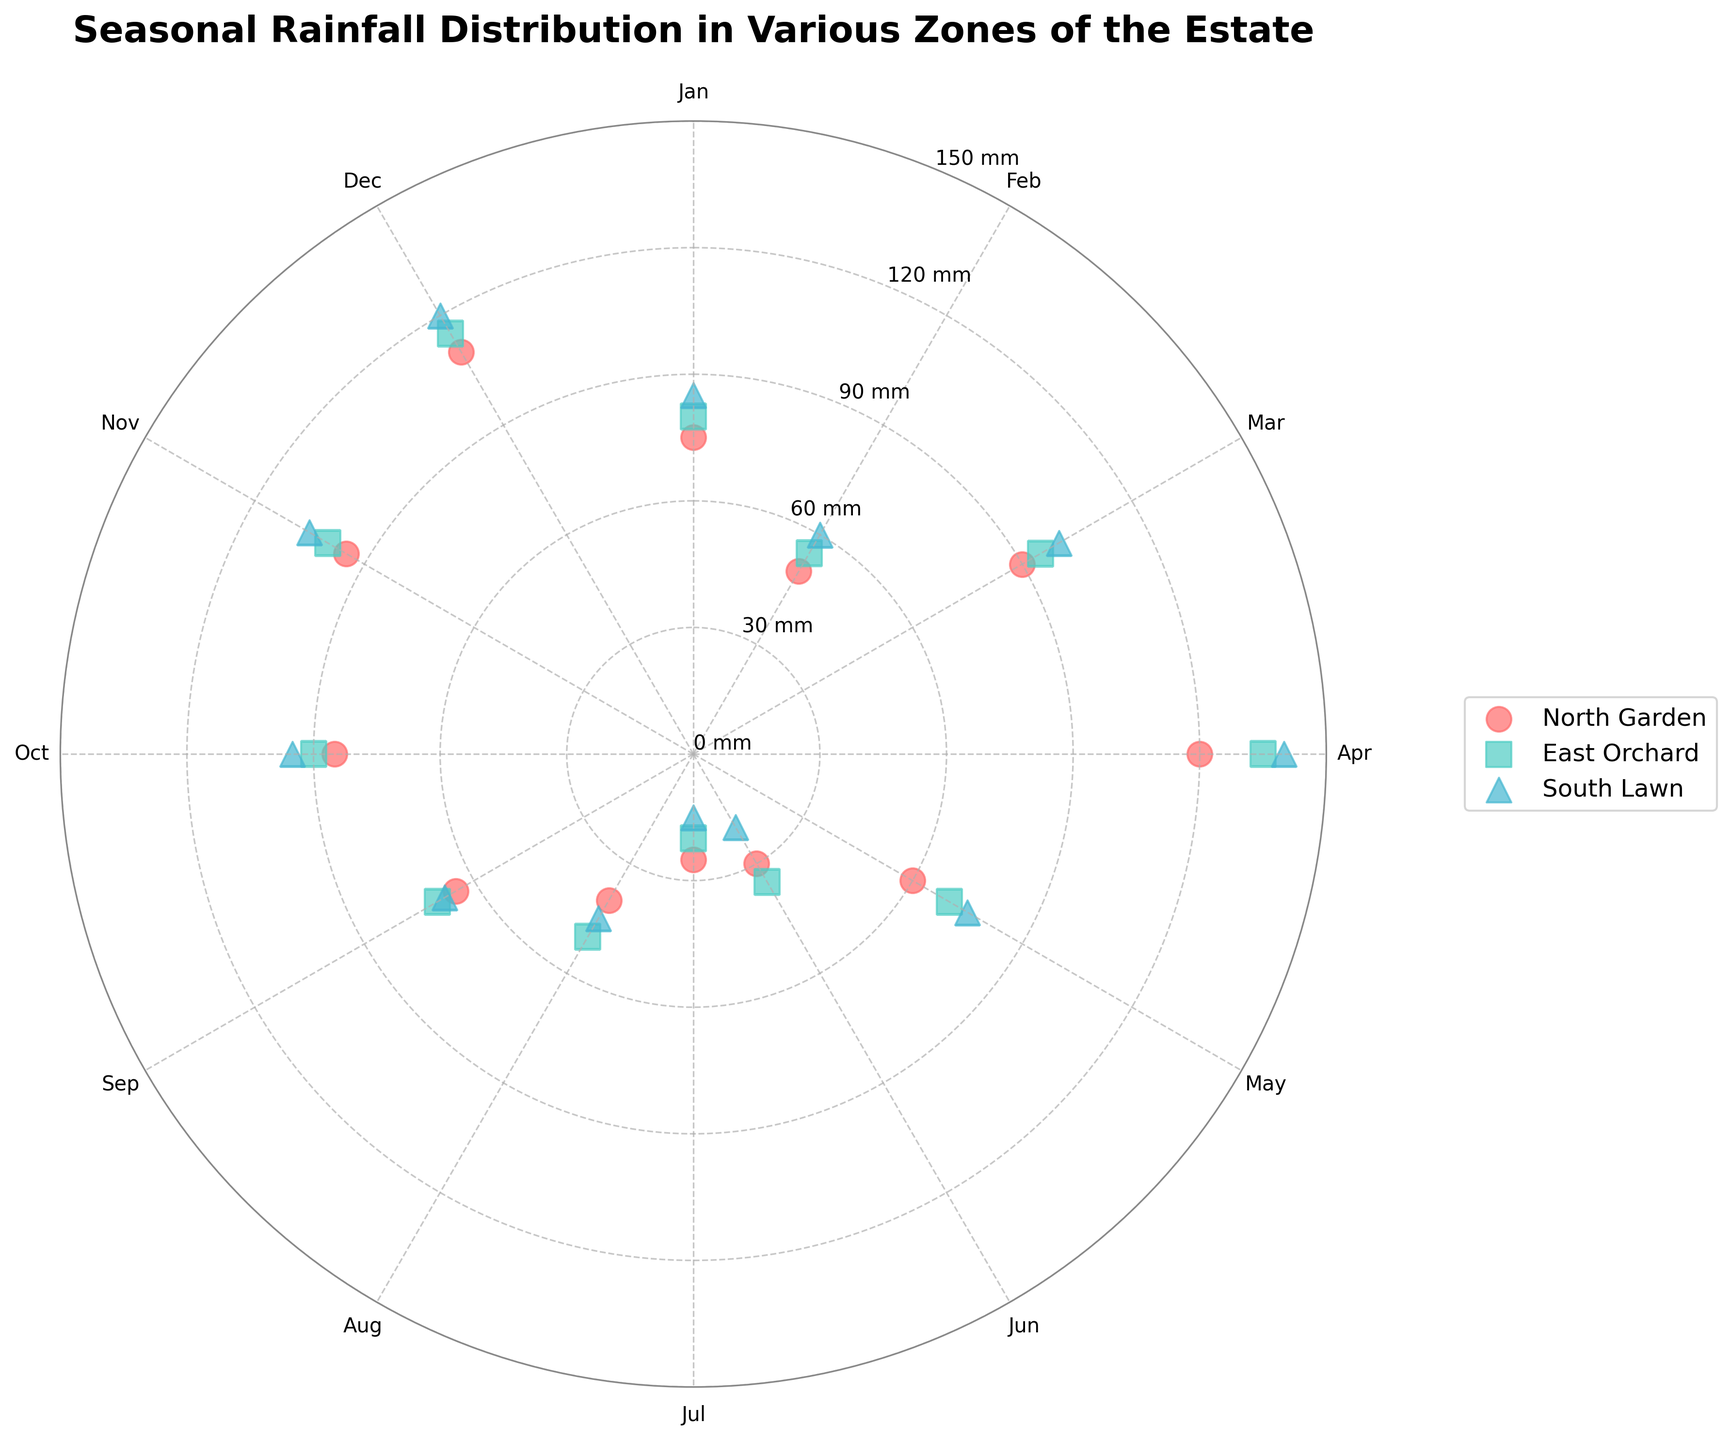what's the title of the chart? The title is prominently displayed at the top of the chart. It provides a summary of what the chart is about, which is helpful for quick identification.
Answer: Seasonal Rainfall Distribution in Various Zones of the Estate how many zones are represented in the chart? The chart includes a legend that lists all the zones represented by different colors and markers. By counting these unique entries, we can determine the number of zones.
Answer: 3 which zone received the highest rainfall in April? Locate the data points for April (90 degrees) and compare their radial distances from the center (indicating rainfall in mm). Identify which zone's point is furthest.
Answer: South Lawn what's the average rainfall in January across all zones? Locate the data points at 0 degrees, find the corresponding rainfall values, then calculate the average: (75 + 80 + 85) / 3 = 80
Answer: 80 mm which month had the lowest rainfall in the North Garden? Identify the data points for the North Garden, compare their radial distances, and find the smallest value.
Answer: July compare the rainfall in July for all zones. Which zone received the least? Locate the data points at 180 degrees for July, then compare the radial distances to find the smallest value.
Answer: South Lawn which zone shows the biggest increase in rainfall from July to August? For each zone, compare the rainfall values at 180 degrees (July) and 210 degrees (August), then find the zone with the largest difference.
Answer: East Orchard does any zone have consistently increasing or decreasing rainfall throughout the year? Examine the radial distances of data points for each zone around the entire circle (January to December) to determine if any zone shows a clear increasing or decreasing pattern without fluctuation.
Answer: No what's the median rainfall value for the East Orchard? List all rainfall values for the East Orchard, arrange them in ascending order, and find the middle value.
Answer: 85 mm which month generally receives the highest rainfall across all zones? For each month, compare the data points of all zones and identify the month with the maximum overall rainfall values.
Answer: April 